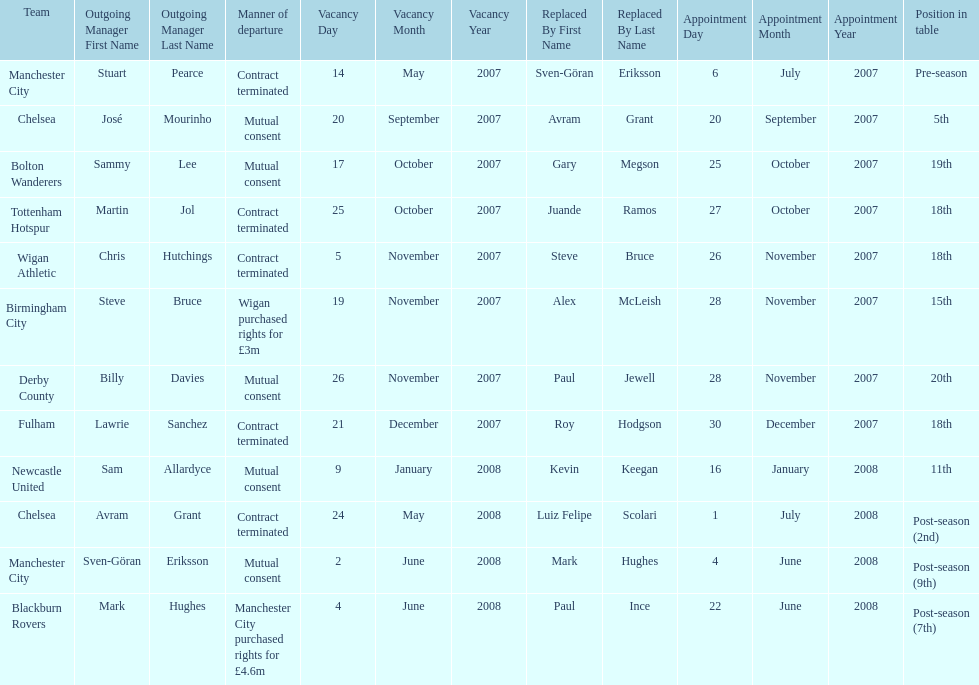Which outgoing manager was appointed the last? Mark Hughes. 